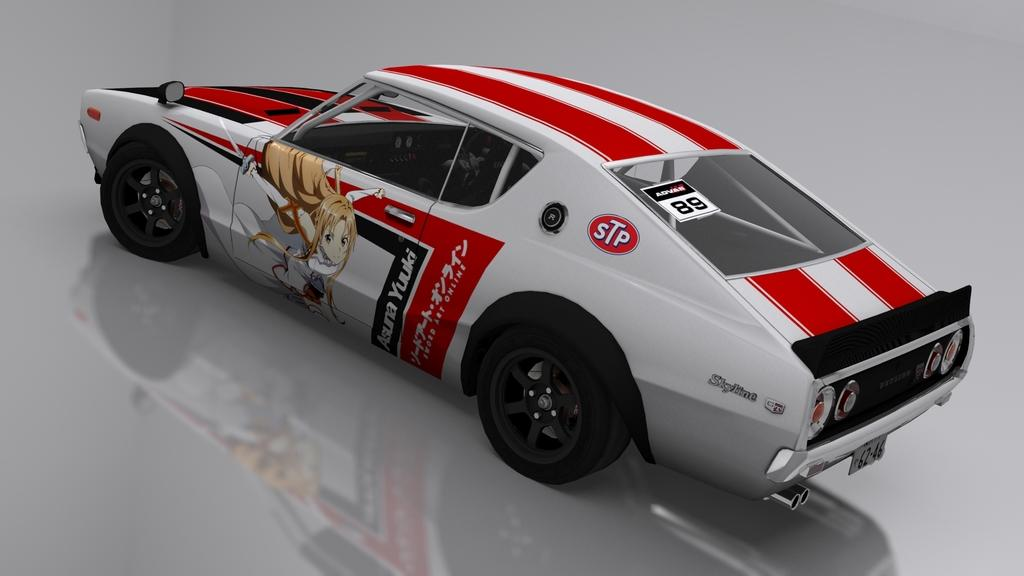What type of image is being described? The image is an animated picture. What can be seen on the surface in the image? There is a car on the surface in the image. What color is the background of the image? The background of the image is white in color. What type of rifle is being gripped by the car in the image? There is no rifle or grip present in the image; it features an animated car on a white background. 